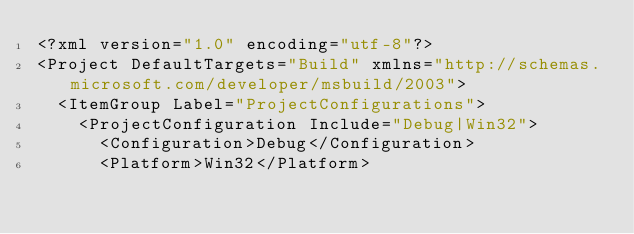<code> <loc_0><loc_0><loc_500><loc_500><_XML_><?xml version="1.0" encoding="utf-8"?>
<Project DefaultTargets="Build" xmlns="http://schemas.microsoft.com/developer/msbuild/2003">
  <ItemGroup Label="ProjectConfigurations">
    <ProjectConfiguration Include="Debug|Win32">
      <Configuration>Debug</Configuration>
      <Platform>Win32</Platform></code> 